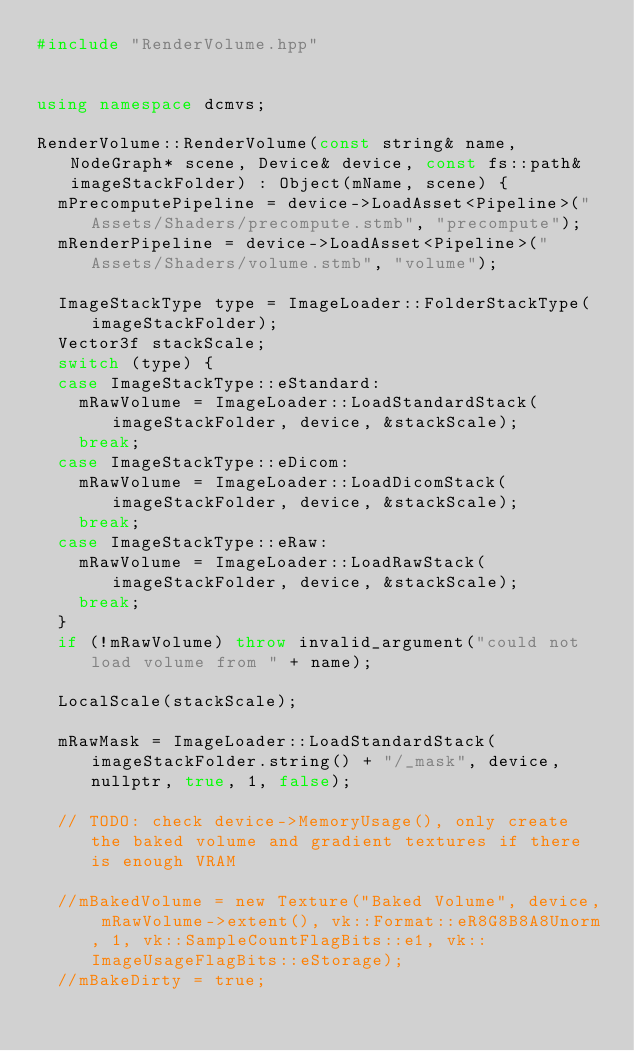Convert code to text. <code><loc_0><loc_0><loc_500><loc_500><_C++_>#include "RenderVolume.hpp"


using namespace dcmvs;

RenderVolume::RenderVolume(const string& name, NodeGraph* scene, Device& device, const fs::path& imageStackFolder) : Object(mName, scene) {
  mPrecomputePipeline = device->LoadAsset<Pipeline>("Assets/Shaders/precompute.stmb", "precompute");
  mRenderPipeline = device->LoadAsset<Pipeline>("Assets/Shaders/volume.stmb", "volume");

  ImageStackType type = ImageLoader::FolderStackType(imageStackFolder);
  Vector3f stackScale;
	switch (type) {
	case ImageStackType::eStandard:
		mRawVolume = ImageLoader::LoadStandardStack(imageStackFolder, device, &stackScale);
		break;
	case ImageStackType::eDicom:
		mRawVolume = ImageLoader::LoadDicomStack(imageStackFolder, device, &stackScale);
		break;
	case ImageStackType::eRaw:
		mRawVolume = ImageLoader::LoadRawStack(imageStackFolder, device, &stackScale);
		break;
	}
	if (!mRawVolume) throw invalid_argument("could not load volume from " + name);

  LocalScale(stackScale);

	mRawMask = ImageLoader::LoadStandardStack(imageStackFolder.string() + "/_mask", device, nullptr, true, 1, false);

	// TODO: check device->MemoryUsage(), only create the baked volume and gradient textures if there is enough VRAM

	//mBakedVolume = new Texture("Baked Volume", device, mRawVolume->extent(), vk::Format::eR8G8B8A8Unorm, 1, vk::SampleCountFlagBits::e1, vk::ImageUsageFlagBits::eStorage);
	//mBakeDirty = true;
</code> 